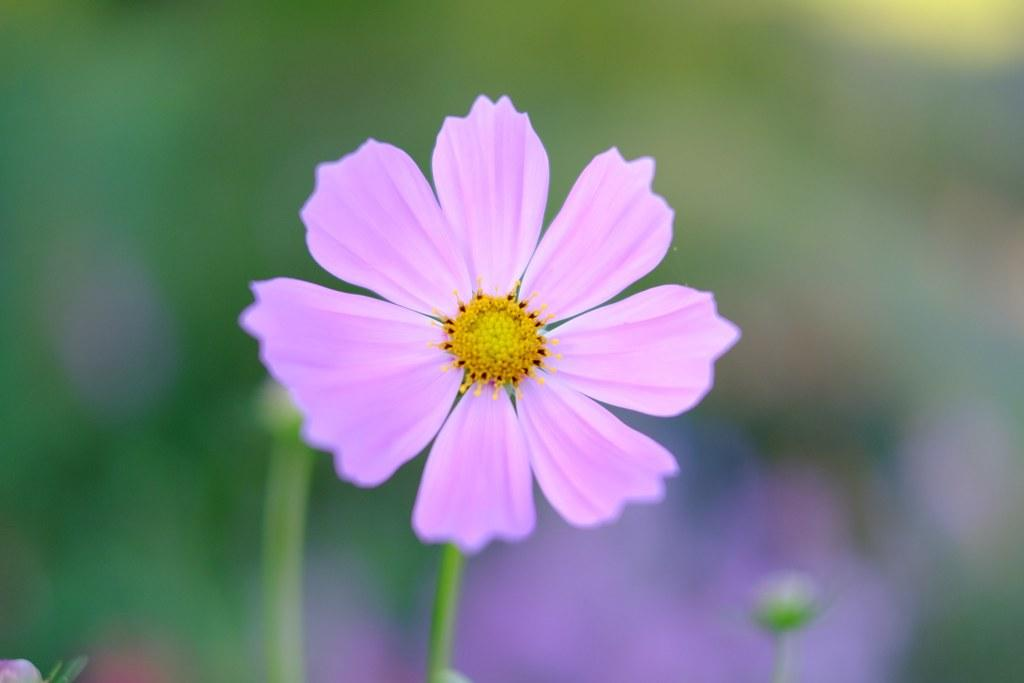What is the main subject of the picture? The main subject of the picture is a flower. Can you describe the color of the flower? The flower is purple. Are there any other flowers in the picture? Yes, there are additional flowers in the picture. What type of sheet is covering the flower in the picture? There is no sheet covering the flower in the picture; it is not present in the image. 